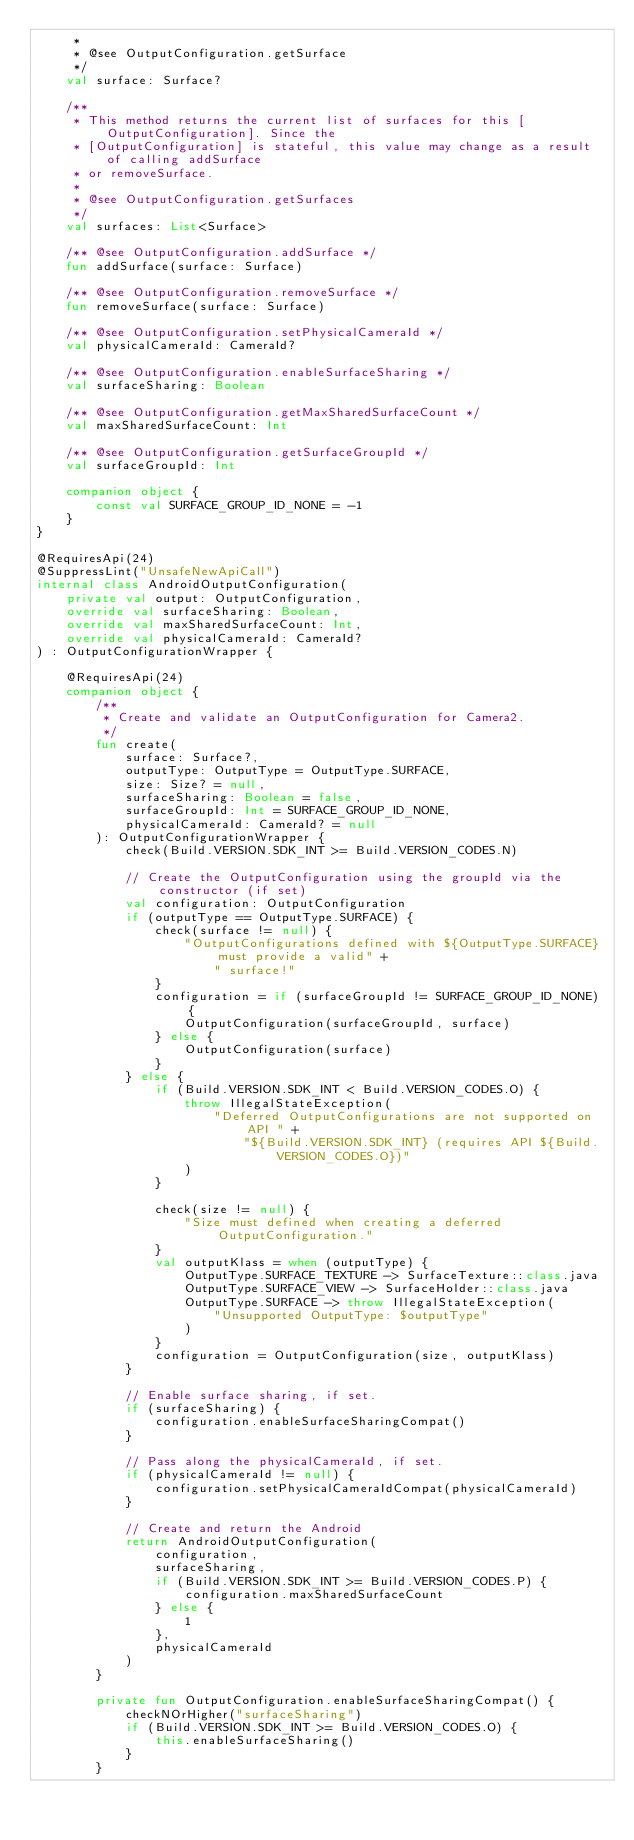Convert code to text. <code><loc_0><loc_0><loc_500><loc_500><_Kotlin_>     *
     * @see OutputConfiguration.getSurface
     */
    val surface: Surface?

    /**
     * This method returns the current list of surfaces for this [OutputConfiguration]. Since the
     * [OutputConfiguration] is stateful, this value may change as a result of calling addSurface
     * or removeSurface.
     *
     * @see OutputConfiguration.getSurfaces
     */
    val surfaces: List<Surface>

    /** @see OutputConfiguration.addSurface */
    fun addSurface(surface: Surface)

    /** @see OutputConfiguration.removeSurface */
    fun removeSurface(surface: Surface)

    /** @see OutputConfiguration.setPhysicalCameraId */
    val physicalCameraId: CameraId?

    /** @see OutputConfiguration.enableSurfaceSharing */
    val surfaceSharing: Boolean

    /** @see OutputConfiguration.getMaxSharedSurfaceCount */
    val maxSharedSurfaceCount: Int

    /** @see OutputConfiguration.getSurfaceGroupId */
    val surfaceGroupId: Int

    companion object {
        const val SURFACE_GROUP_ID_NONE = -1
    }
}

@RequiresApi(24)
@SuppressLint("UnsafeNewApiCall")
internal class AndroidOutputConfiguration(
    private val output: OutputConfiguration,
    override val surfaceSharing: Boolean,
    override val maxSharedSurfaceCount: Int,
    override val physicalCameraId: CameraId?
) : OutputConfigurationWrapper {

    @RequiresApi(24)
    companion object {
        /**
         * Create and validate an OutputConfiguration for Camera2.
         */
        fun create(
            surface: Surface?,
            outputType: OutputType = OutputType.SURFACE,
            size: Size? = null,
            surfaceSharing: Boolean = false,
            surfaceGroupId: Int = SURFACE_GROUP_ID_NONE,
            physicalCameraId: CameraId? = null
        ): OutputConfigurationWrapper {
            check(Build.VERSION.SDK_INT >= Build.VERSION_CODES.N)

            // Create the OutputConfiguration using the groupId via the constructor (if set)
            val configuration: OutputConfiguration
            if (outputType == OutputType.SURFACE) {
                check(surface != null) {
                    "OutputConfigurations defined with ${OutputType.SURFACE} must provide a valid" +
                        " surface!"
                }
                configuration = if (surfaceGroupId != SURFACE_GROUP_ID_NONE) {
                    OutputConfiguration(surfaceGroupId, surface)
                } else {
                    OutputConfiguration(surface)
                }
            } else {
                if (Build.VERSION.SDK_INT < Build.VERSION_CODES.O) {
                    throw IllegalStateException(
                        "Deferred OutputConfigurations are not supported on API " +
                            "${Build.VERSION.SDK_INT} (requires API ${Build.VERSION_CODES.O})"
                    )
                }

                check(size != null) {
                    "Size must defined when creating a deferred OutputConfiguration."
                }
                val outputKlass = when (outputType) {
                    OutputType.SURFACE_TEXTURE -> SurfaceTexture::class.java
                    OutputType.SURFACE_VIEW -> SurfaceHolder::class.java
                    OutputType.SURFACE -> throw IllegalStateException(
                        "Unsupported OutputType: $outputType"
                    )
                }
                configuration = OutputConfiguration(size, outputKlass)
            }

            // Enable surface sharing, if set.
            if (surfaceSharing) {
                configuration.enableSurfaceSharingCompat()
            }

            // Pass along the physicalCameraId, if set.
            if (physicalCameraId != null) {
                configuration.setPhysicalCameraIdCompat(physicalCameraId)
            }

            // Create and return the Android
            return AndroidOutputConfiguration(
                configuration,
                surfaceSharing,
                if (Build.VERSION.SDK_INT >= Build.VERSION_CODES.P) {
                    configuration.maxSharedSurfaceCount
                } else {
                    1
                },
                physicalCameraId
            )
        }

        private fun OutputConfiguration.enableSurfaceSharingCompat() {
            checkNOrHigher("surfaceSharing")
            if (Build.VERSION.SDK_INT >= Build.VERSION_CODES.O) {
                this.enableSurfaceSharing()
            }
        }
</code> 